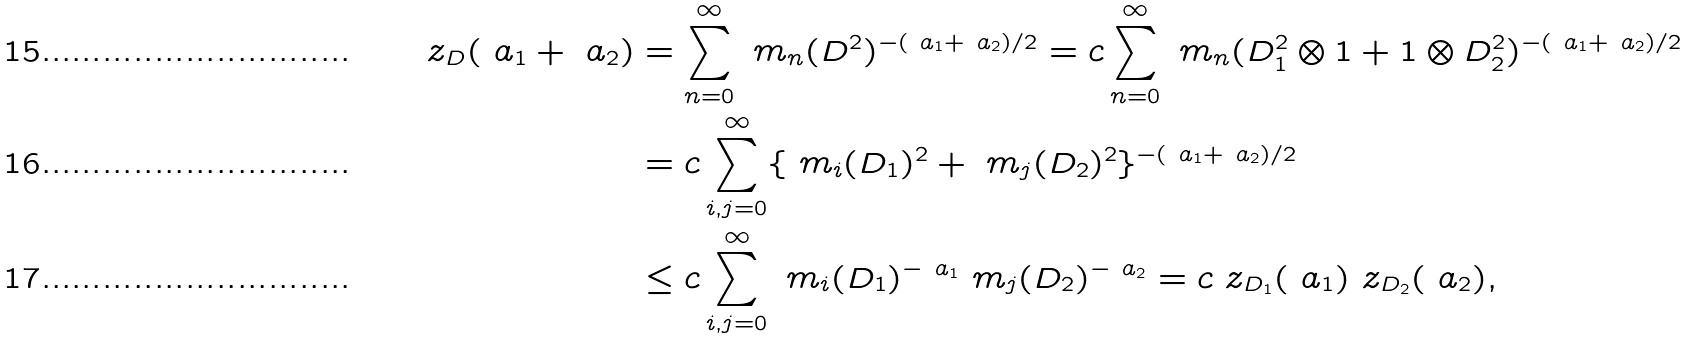<formula> <loc_0><loc_0><loc_500><loc_500>\ z _ { D } ( \ a _ { 1 } + \ a _ { 2 } ) & = \sum _ { n = 0 } ^ { \infty } \ m _ { n } ( D ^ { 2 } ) ^ { - ( \ a _ { 1 } + \ a _ { 2 } ) / 2 } = c \sum _ { n = 0 } ^ { \infty } \ m _ { n } ( D _ { 1 } ^ { 2 } \otimes 1 + 1 \otimes D _ { 2 } ^ { 2 } ) ^ { - ( \ a _ { 1 } + \ a _ { 2 } ) / 2 } \\ & = c \sum _ { i , j = 0 } ^ { \infty } \{ \ m _ { i } ( D _ { 1 } ) ^ { 2 } + \ m _ { j } ( D _ { 2 } ) ^ { 2 } \} ^ { - ( \ a _ { 1 } + \ a _ { 2 } ) / 2 } \\ & \leq c \sum _ { i , j = 0 } ^ { \infty } \ m _ { i } ( D _ { 1 } ) ^ { - \ a _ { 1 } } \ m _ { j } ( D _ { 2 } ) ^ { - \ a _ { 2 } } = c \ z _ { D _ { 1 } } ( \ a _ { 1 } ) \ z _ { D _ { 2 } } ( \ a _ { 2 } ) ,</formula> 